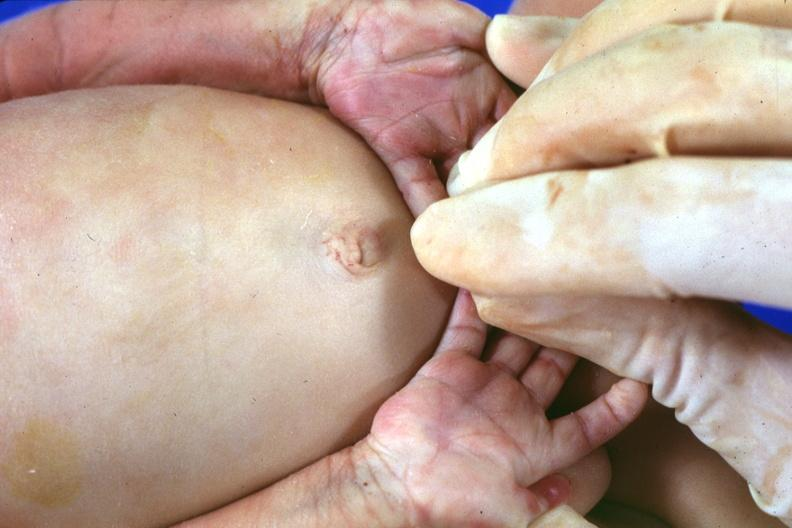does this image show simian crease?
Answer the question using a single word or phrase. Yes 